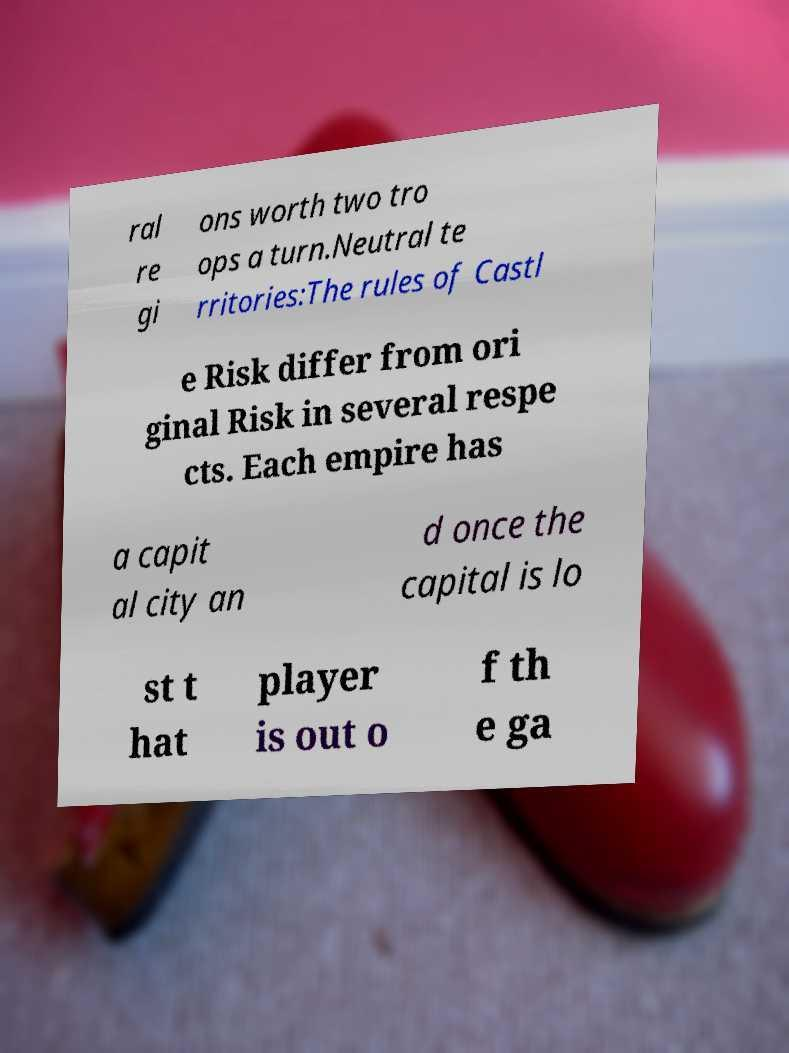Can you accurately transcribe the text from the provided image for me? ral re gi ons worth two tro ops a turn.Neutral te rritories:The rules of Castl e Risk differ from ori ginal Risk in several respe cts. Each empire has a capit al city an d once the capital is lo st t hat player is out o f th e ga 